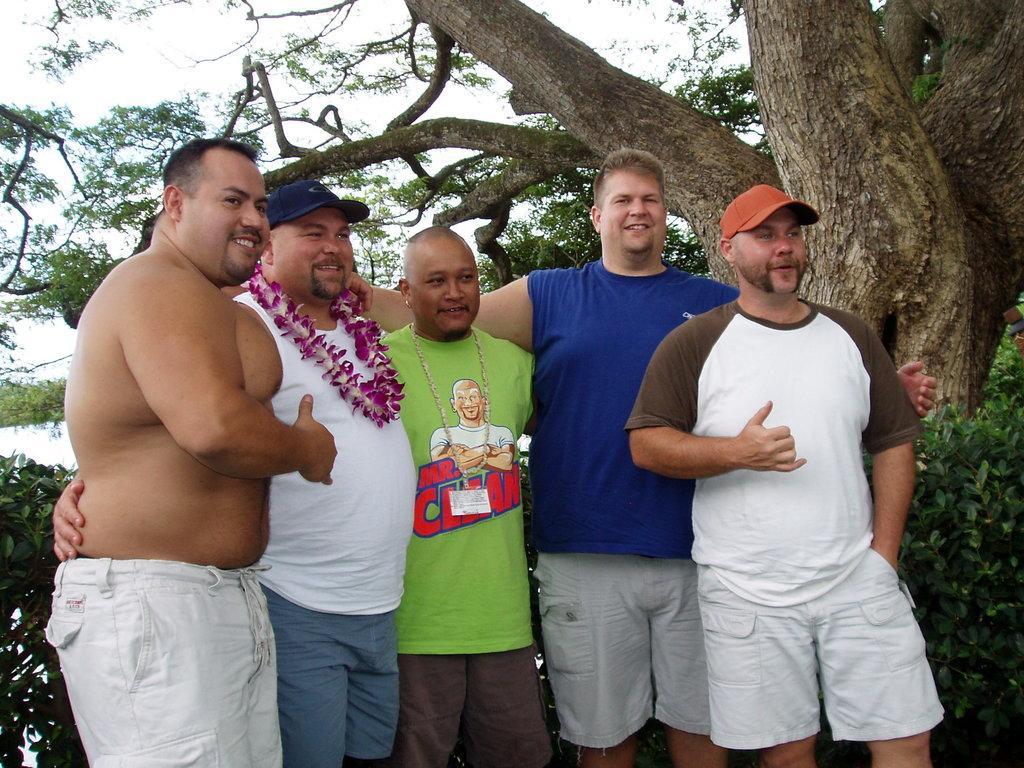Please provide a concise description of this image. In the center of the image we can see a few people are standing and they are smiling. Among them, we can see two persons are wearing caps and one person wearing a flower garland. In the background we can see the sky, clouds, trees, plants etc. 